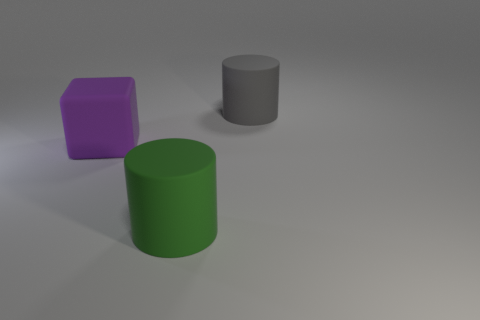What size is the matte cylinder in front of the gray cylinder?
Offer a very short reply. Large. There is a rubber object that is left of the large green matte cylinder; does it have the same shape as the big green thing?
Offer a terse response. No. Are there any gray objects that have the same size as the rubber block?
Offer a terse response. Yes. Is there a big cylinder that is in front of the matte cylinder behind the thing that is in front of the matte block?
Make the answer very short. Yes. What is the shape of the thing in front of the purple matte thing?
Ensure brevity in your answer.  Cylinder. What size is the gray thing that is the same material as the big purple cube?
Give a very brief answer. Large. What number of large green rubber objects are the same shape as the gray object?
Your answer should be compact. 1. How many large matte things are to the right of the cylinder on the left side of the large gray rubber cylinder to the right of the green object?
Provide a short and direct response. 1. What number of big rubber objects are both right of the purple block and behind the large green object?
Provide a succinct answer. 1. Do the gray thing and the big green thing have the same material?
Offer a very short reply. Yes. 